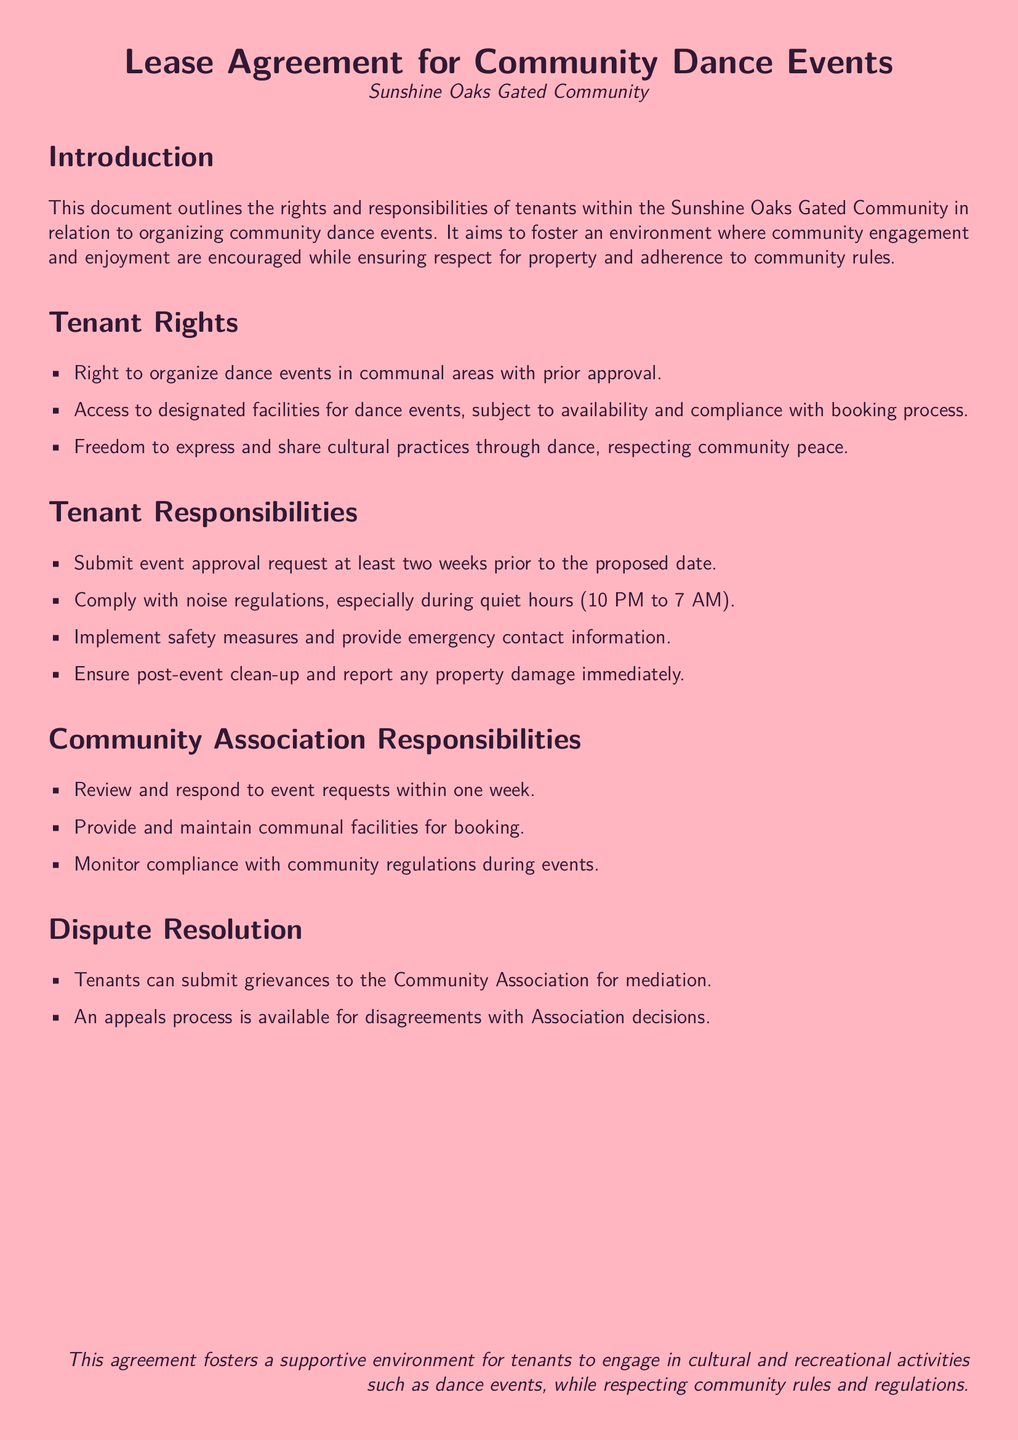What is the title of the document? The title of the document is given in the center at the beginning, identifying it as related to community dance events in Sunshine Oaks.
Answer: Lease Agreement for Community Dance Events What is the quiet hours time frame? The quiet hours are mentioned explicitly in the responsibilities section, indicating when noise regulations must be adhered to.
Answer: 10 PM to 7 AM How many weeks in advance must event approval requests be submitted? The document specifies a timeline for submitting requests, indicating the necessary time frame for organization.
Answer: Two weeks Who is responsible for post-event clean-up? The tenant responsibilities section states the duties of tenants after organizing events, specifying who must ensure cleanliness.
Answer: Tenants What is the time frame for the Community Association to respond to event requests? The document includes a clear timeline for how quickly the Community Association should address tenant requests.
Answer: One week What should tenants provide regarding safety measures? Tenants are required to implement certain protocols during events, as detailed in the responsibilities section, focusing on safety.
Answer: Emergency contact information What is the main aim of this lease agreement? The introduction outlines the purpose of the document, which is to promote certain values within the community.
Answer: Foster community engagement What options do tenants have for disputing decisions? The dispute resolution section outlines available processes for tenants to follow when they have grievances, indicating how to address conflicts.
Answer: Mediation and appeals process 